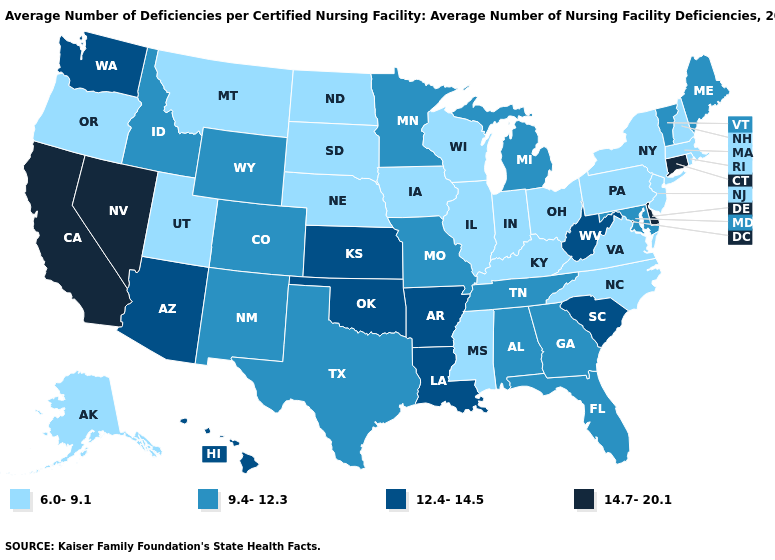Is the legend a continuous bar?
Answer briefly. No. What is the lowest value in the USA?
Short answer required. 6.0-9.1. What is the highest value in states that border New Jersey?
Be succinct. 14.7-20.1. What is the highest value in the USA?
Keep it brief. 14.7-20.1. Name the states that have a value in the range 9.4-12.3?
Keep it brief. Alabama, Colorado, Florida, Georgia, Idaho, Maine, Maryland, Michigan, Minnesota, Missouri, New Mexico, Tennessee, Texas, Vermont, Wyoming. Among the states that border Rhode Island , does Connecticut have the lowest value?
Answer briefly. No. What is the value of Maine?
Answer briefly. 9.4-12.3. What is the value of Alaska?
Short answer required. 6.0-9.1. Does Texas have the same value as Alaska?
Concise answer only. No. Name the states that have a value in the range 9.4-12.3?
Give a very brief answer. Alabama, Colorado, Florida, Georgia, Idaho, Maine, Maryland, Michigan, Minnesota, Missouri, New Mexico, Tennessee, Texas, Vermont, Wyoming. Name the states that have a value in the range 12.4-14.5?
Write a very short answer. Arizona, Arkansas, Hawaii, Kansas, Louisiana, Oklahoma, South Carolina, Washington, West Virginia. Does Nevada have the highest value in the USA?
Give a very brief answer. Yes. Does the map have missing data?
Short answer required. No. Name the states that have a value in the range 6.0-9.1?
Quick response, please. Alaska, Illinois, Indiana, Iowa, Kentucky, Massachusetts, Mississippi, Montana, Nebraska, New Hampshire, New Jersey, New York, North Carolina, North Dakota, Ohio, Oregon, Pennsylvania, Rhode Island, South Dakota, Utah, Virginia, Wisconsin. Does California have the highest value in the West?
Be succinct. Yes. 